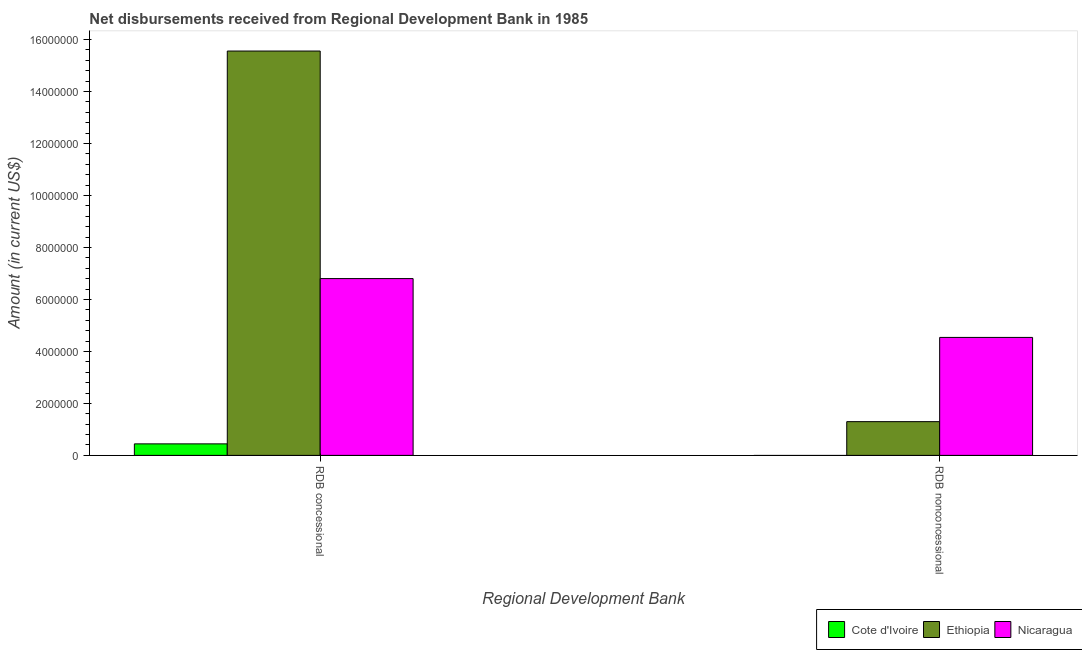How many different coloured bars are there?
Provide a short and direct response. 3. Are the number of bars per tick equal to the number of legend labels?
Your response must be concise. No. Are the number of bars on each tick of the X-axis equal?
Give a very brief answer. No. What is the label of the 1st group of bars from the left?
Give a very brief answer. RDB concessional. Across all countries, what is the maximum net concessional disbursements from rdb?
Ensure brevity in your answer.  1.56e+07. Across all countries, what is the minimum net concessional disbursements from rdb?
Your answer should be compact. 4.43e+05. In which country was the net non concessional disbursements from rdb maximum?
Provide a short and direct response. Nicaragua. What is the total net concessional disbursements from rdb in the graph?
Give a very brief answer. 2.28e+07. What is the difference between the net concessional disbursements from rdb in Nicaragua and that in Ethiopia?
Your answer should be very brief. -8.76e+06. What is the difference between the net concessional disbursements from rdb in Cote d'Ivoire and the net non concessional disbursements from rdb in Nicaragua?
Offer a terse response. -4.10e+06. What is the average net non concessional disbursements from rdb per country?
Your answer should be very brief. 1.95e+06. What is the difference between the net non concessional disbursements from rdb and net concessional disbursements from rdb in Ethiopia?
Offer a terse response. -1.43e+07. What is the ratio of the net concessional disbursements from rdb in Ethiopia to that in Nicaragua?
Your answer should be compact. 2.29. Is the net non concessional disbursements from rdb in Nicaragua less than that in Ethiopia?
Your answer should be very brief. No. In how many countries, is the net concessional disbursements from rdb greater than the average net concessional disbursements from rdb taken over all countries?
Provide a short and direct response. 1. How many bars are there?
Your answer should be very brief. 5. Are the values on the major ticks of Y-axis written in scientific E-notation?
Your response must be concise. No. Does the graph contain grids?
Your answer should be compact. No. How many legend labels are there?
Give a very brief answer. 3. What is the title of the graph?
Give a very brief answer. Net disbursements received from Regional Development Bank in 1985. Does "Australia" appear as one of the legend labels in the graph?
Offer a terse response. No. What is the label or title of the X-axis?
Your response must be concise. Regional Development Bank. What is the label or title of the Y-axis?
Provide a short and direct response. Amount (in current US$). What is the Amount (in current US$) in Cote d'Ivoire in RDB concessional?
Your answer should be compact. 4.43e+05. What is the Amount (in current US$) of Ethiopia in RDB concessional?
Provide a short and direct response. 1.56e+07. What is the Amount (in current US$) in Nicaragua in RDB concessional?
Provide a short and direct response. 6.80e+06. What is the Amount (in current US$) of Cote d'Ivoire in RDB nonconcessional?
Provide a short and direct response. 0. What is the Amount (in current US$) in Ethiopia in RDB nonconcessional?
Your answer should be compact. 1.30e+06. What is the Amount (in current US$) in Nicaragua in RDB nonconcessional?
Keep it short and to the point. 4.54e+06. Across all Regional Development Bank, what is the maximum Amount (in current US$) in Cote d'Ivoire?
Ensure brevity in your answer.  4.43e+05. Across all Regional Development Bank, what is the maximum Amount (in current US$) of Ethiopia?
Ensure brevity in your answer.  1.56e+07. Across all Regional Development Bank, what is the maximum Amount (in current US$) of Nicaragua?
Ensure brevity in your answer.  6.80e+06. Across all Regional Development Bank, what is the minimum Amount (in current US$) in Ethiopia?
Give a very brief answer. 1.30e+06. Across all Regional Development Bank, what is the minimum Amount (in current US$) in Nicaragua?
Offer a very short reply. 4.54e+06. What is the total Amount (in current US$) of Cote d'Ivoire in the graph?
Your response must be concise. 4.43e+05. What is the total Amount (in current US$) of Ethiopia in the graph?
Your answer should be very brief. 1.69e+07. What is the total Amount (in current US$) in Nicaragua in the graph?
Your answer should be compact. 1.13e+07. What is the difference between the Amount (in current US$) of Ethiopia in RDB concessional and that in RDB nonconcessional?
Provide a short and direct response. 1.43e+07. What is the difference between the Amount (in current US$) in Nicaragua in RDB concessional and that in RDB nonconcessional?
Keep it short and to the point. 2.26e+06. What is the difference between the Amount (in current US$) of Cote d'Ivoire in RDB concessional and the Amount (in current US$) of Ethiopia in RDB nonconcessional?
Your answer should be compact. -8.55e+05. What is the difference between the Amount (in current US$) in Cote d'Ivoire in RDB concessional and the Amount (in current US$) in Nicaragua in RDB nonconcessional?
Your answer should be compact. -4.10e+06. What is the difference between the Amount (in current US$) in Ethiopia in RDB concessional and the Amount (in current US$) in Nicaragua in RDB nonconcessional?
Ensure brevity in your answer.  1.10e+07. What is the average Amount (in current US$) in Cote d'Ivoire per Regional Development Bank?
Offer a terse response. 2.22e+05. What is the average Amount (in current US$) in Ethiopia per Regional Development Bank?
Your response must be concise. 8.43e+06. What is the average Amount (in current US$) in Nicaragua per Regional Development Bank?
Your response must be concise. 5.67e+06. What is the difference between the Amount (in current US$) in Cote d'Ivoire and Amount (in current US$) in Ethiopia in RDB concessional?
Provide a short and direct response. -1.51e+07. What is the difference between the Amount (in current US$) of Cote d'Ivoire and Amount (in current US$) of Nicaragua in RDB concessional?
Offer a terse response. -6.36e+06. What is the difference between the Amount (in current US$) of Ethiopia and Amount (in current US$) of Nicaragua in RDB concessional?
Provide a succinct answer. 8.76e+06. What is the difference between the Amount (in current US$) of Ethiopia and Amount (in current US$) of Nicaragua in RDB nonconcessional?
Offer a very short reply. -3.24e+06. What is the ratio of the Amount (in current US$) in Ethiopia in RDB concessional to that in RDB nonconcessional?
Your answer should be compact. 11.99. What is the ratio of the Amount (in current US$) in Nicaragua in RDB concessional to that in RDB nonconcessional?
Give a very brief answer. 1.5. What is the difference between the highest and the second highest Amount (in current US$) of Ethiopia?
Offer a terse response. 1.43e+07. What is the difference between the highest and the second highest Amount (in current US$) of Nicaragua?
Offer a very short reply. 2.26e+06. What is the difference between the highest and the lowest Amount (in current US$) in Cote d'Ivoire?
Offer a terse response. 4.43e+05. What is the difference between the highest and the lowest Amount (in current US$) of Ethiopia?
Your response must be concise. 1.43e+07. What is the difference between the highest and the lowest Amount (in current US$) of Nicaragua?
Provide a short and direct response. 2.26e+06. 